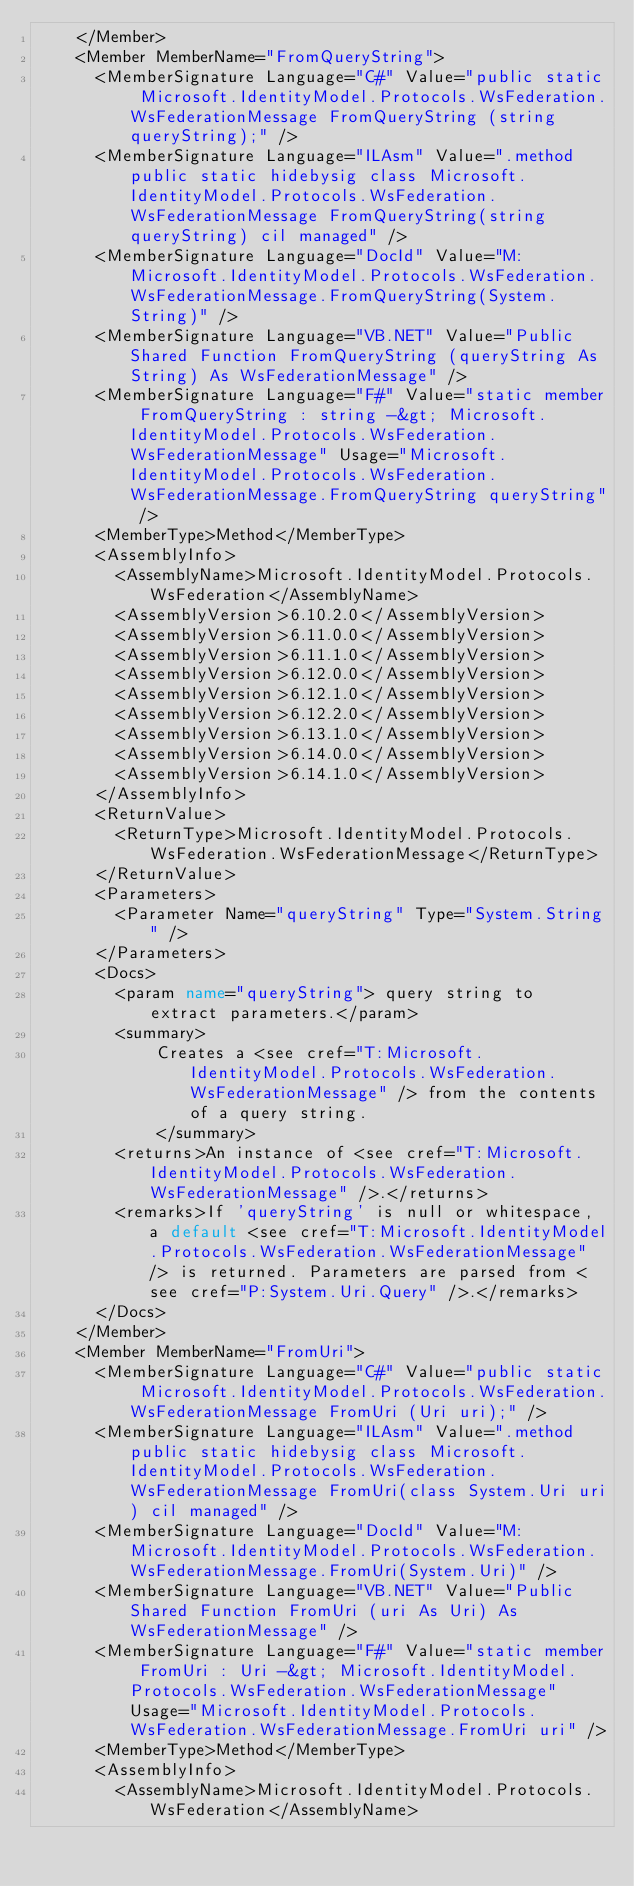<code> <loc_0><loc_0><loc_500><loc_500><_XML_>    </Member>
    <Member MemberName="FromQueryString">
      <MemberSignature Language="C#" Value="public static Microsoft.IdentityModel.Protocols.WsFederation.WsFederationMessage FromQueryString (string queryString);" />
      <MemberSignature Language="ILAsm" Value=".method public static hidebysig class Microsoft.IdentityModel.Protocols.WsFederation.WsFederationMessage FromQueryString(string queryString) cil managed" />
      <MemberSignature Language="DocId" Value="M:Microsoft.IdentityModel.Protocols.WsFederation.WsFederationMessage.FromQueryString(System.String)" />
      <MemberSignature Language="VB.NET" Value="Public Shared Function FromQueryString (queryString As String) As WsFederationMessage" />
      <MemberSignature Language="F#" Value="static member FromQueryString : string -&gt; Microsoft.IdentityModel.Protocols.WsFederation.WsFederationMessage" Usage="Microsoft.IdentityModel.Protocols.WsFederation.WsFederationMessage.FromQueryString queryString" />
      <MemberType>Method</MemberType>
      <AssemblyInfo>
        <AssemblyName>Microsoft.IdentityModel.Protocols.WsFederation</AssemblyName>
        <AssemblyVersion>6.10.2.0</AssemblyVersion>
        <AssemblyVersion>6.11.0.0</AssemblyVersion>
        <AssemblyVersion>6.11.1.0</AssemblyVersion>
        <AssemblyVersion>6.12.0.0</AssemblyVersion>
        <AssemblyVersion>6.12.1.0</AssemblyVersion>
        <AssemblyVersion>6.12.2.0</AssemblyVersion>
        <AssemblyVersion>6.13.1.0</AssemblyVersion>
        <AssemblyVersion>6.14.0.0</AssemblyVersion>
        <AssemblyVersion>6.14.1.0</AssemblyVersion>
      </AssemblyInfo>
      <ReturnValue>
        <ReturnType>Microsoft.IdentityModel.Protocols.WsFederation.WsFederationMessage</ReturnType>
      </ReturnValue>
      <Parameters>
        <Parameter Name="queryString" Type="System.String" />
      </Parameters>
      <Docs>
        <param name="queryString"> query string to extract parameters.</param>
        <summary>
            Creates a <see cref="T:Microsoft.IdentityModel.Protocols.WsFederation.WsFederationMessage" /> from the contents of a query string.
            </summary>
        <returns>An instance of <see cref="T:Microsoft.IdentityModel.Protocols.WsFederation.WsFederationMessage" />.</returns>
        <remarks>If 'queryString' is null or whitespace, a default <see cref="T:Microsoft.IdentityModel.Protocols.WsFederation.WsFederationMessage" /> is returned. Parameters are parsed from <see cref="P:System.Uri.Query" />.</remarks>
      </Docs>
    </Member>
    <Member MemberName="FromUri">
      <MemberSignature Language="C#" Value="public static Microsoft.IdentityModel.Protocols.WsFederation.WsFederationMessage FromUri (Uri uri);" />
      <MemberSignature Language="ILAsm" Value=".method public static hidebysig class Microsoft.IdentityModel.Protocols.WsFederation.WsFederationMessage FromUri(class System.Uri uri) cil managed" />
      <MemberSignature Language="DocId" Value="M:Microsoft.IdentityModel.Protocols.WsFederation.WsFederationMessage.FromUri(System.Uri)" />
      <MemberSignature Language="VB.NET" Value="Public Shared Function FromUri (uri As Uri) As WsFederationMessage" />
      <MemberSignature Language="F#" Value="static member FromUri : Uri -&gt; Microsoft.IdentityModel.Protocols.WsFederation.WsFederationMessage" Usage="Microsoft.IdentityModel.Protocols.WsFederation.WsFederationMessage.FromUri uri" />
      <MemberType>Method</MemberType>
      <AssemblyInfo>
        <AssemblyName>Microsoft.IdentityModel.Protocols.WsFederation</AssemblyName></code> 